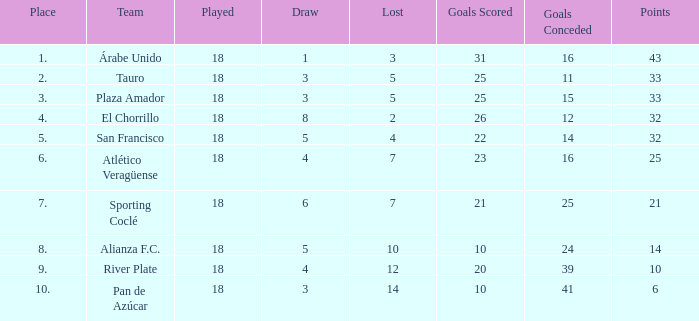How many goals were conceded by the team with more than 21 points more than 5 draws and less than 18 games played? None. 